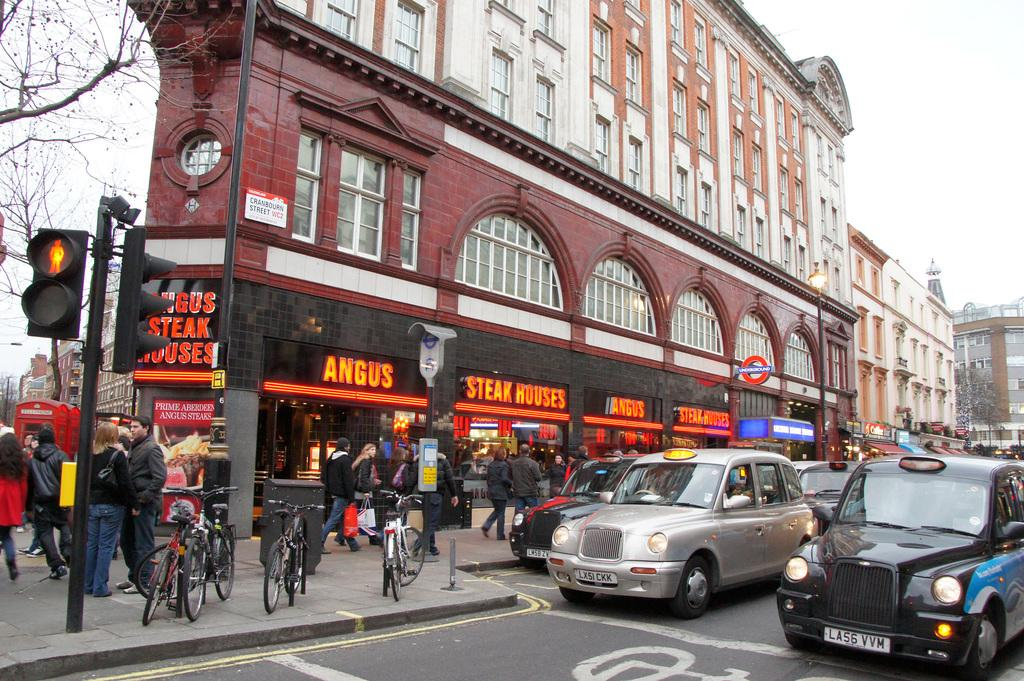Provide a one-sentence caption for the provided image. A busy sidewalk with people and bikes on it and signs that say Angus Steak Houses. 